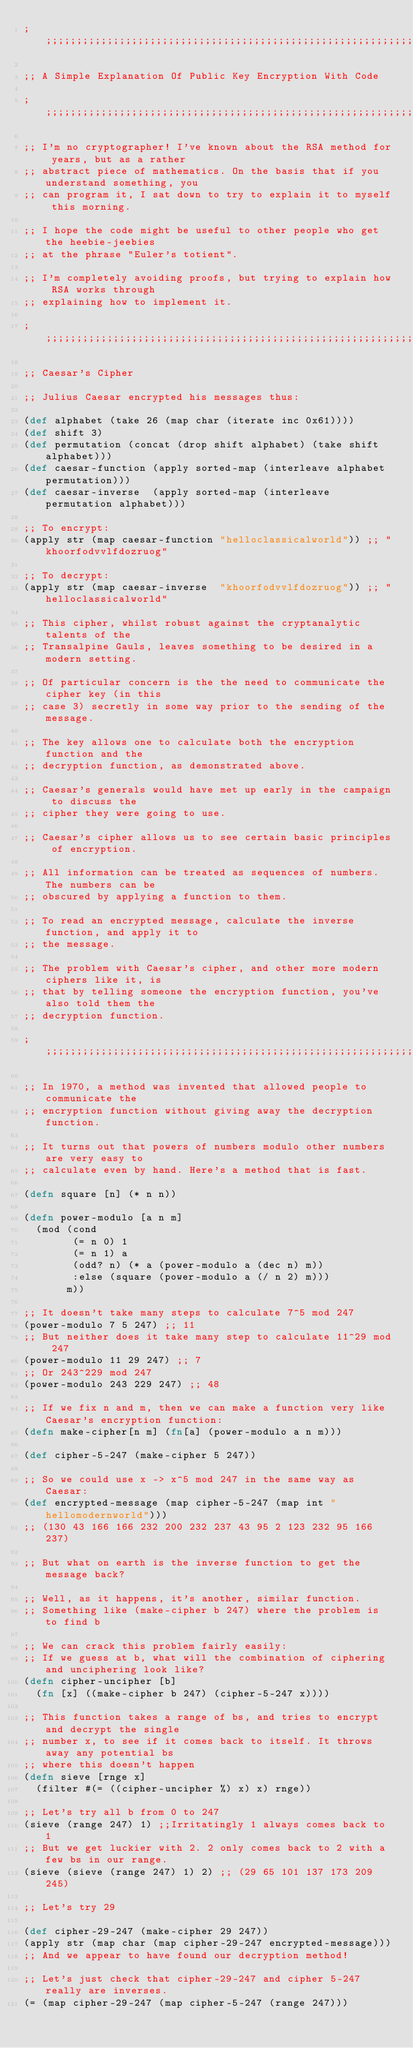<code> <loc_0><loc_0><loc_500><loc_500><_Clojure_>;;;;;;;;;;;;;;;;;;;;;;;;;;;;;;;;;;;;;;;;;;;;;;;;;;;;;;;;;;;;;;;;;;;;;;;;;;;;;;;;;;;;;;;;;;;

;; A Simple Explanation Of Public Key Encryption With Code

;;;;;;;;;;;;;;;;;;;;;;;;;;;;;;;;;;;;;;;;;;;;;;;;;;;;;;;;;;;;;;;;;;;;;;;;;;;;;;;;;;;;;;;;;;;

;; I'm no cryptographer! I've known about the RSA method for years, but as a rather
;; abstract piece of mathematics. On the basis that if you understand something, you
;; can program it, I sat down to try to explain it to myself this morning.

;; I hope the code might be useful to other people who get the heebie-jeebies
;; at the phrase "Euler's totient".

;; I'm completely avoiding proofs, but trying to explain how RSA works through
;; explaining how to implement it.

;;;;;;;;;;;;;;;;;;;;;;;;;;;;;;;;;;;;;;;;;;;;;;;;;;;;;;;;;;;;;;;;;;;;;;;;;;;;;;;;;;;;;;;;;;;;

;; Caesar's Cipher

;; Julius Caesar encrypted his messages thus:

(def alphabet (take 26 (map char (iterate inc 0x61))))
(def shift 3)
(def permutation (concat (drop shift alphabet) (take shift alphabet)))
(def caesar-function (apply sorted-map (interleave alphabet permutation)))
(def caesar-inverse  (apply sorted-map (interleave permutation alphabet)))

;; To encrypt:
(apply str (map caesar-function "helloclassicalworld")) ;; "khoorfodvvlfdozruog"

;; To decrypt:
(apply str (map caesar-inverse  "khoorfodvvlfdozruog")) ;; "helloclassicalworld"

;; This cipher, whilst robust against the cryptanalytic talents of the
;; Transalpine Gauls, leaves something to be desired in a modern setting.

;; Of particular concern is the the need to communicate the cipher key (in this
;; case 3) secretly in some way prior to the sending of the message.

;; The key allows one to calculate both the encryption function and the
;; decryption function, as demonstrated above.

;; Caesar's generals would have met up early in the campaign to discuss the
;; cipher they were going to use.

;; Caesar's cipher allows us to see certain basic principles of encryption.

;; All information can be treated as sequences of numbers.  The numbers can be
;; obscured by applying a function to them.

;; To read an encrypted message, calculate the inverse function, and apply it to
;; the message.

;; The problem with Caesar's cipher, and other more modern ciphers like it, is
;; that by telling someone the encryption function, you've also told them the
;; decryption function.

;;;;;;;;;;;;;;;;;;;;;;;;;;;;;;;;;;;;;;;;;;;;;;;;;;;;;;;;;;;;;;;;;;;;;;;;;;;;;;;;;;;;;;;;;;;;;;;

;; In 1970, a method was invented that allowed people to communicate the
;; encryption function without giving away the decryption function.

;; It turns out that powers of numbers modulo other numbers are very easy to
;; calculate even by hand. Here's a method that is fast.

(defn square [n] (* n n))

(defn power-modulo [a n m]
  (mod (cond
        (= n 0) 1
        (= n 1) a
        (odd? n) (* a (power-modulo a (dec n) m))
        :else (square (power-modulo a (/ n 2) m)))
       m))

;; It doesn't take many steps to calculate 7^5 mod 247 
(power-modulo 7 5 247) ;; 11
;; But neither does it take many step to calculate 11^29 mod 247
(power-modulo 11 29 247) ;; 7
;; Or 243^229 mod 247
(power-modulo 243 229 247) ;; 48

;; If we fix n and m, then we can make a function very like Caesar's encryption function:
(defn make-cipher[n m] (fn[a] (power-modulo a n m)))

(def cipher-5-247 (make-cipher 5 247))

;; So we could use x -> x^5 mod 247 in the same way as Caesar:
(def encrypted-message (map cipher-5-247 (map int "hellomodernworld")))
;; (130 43 166 166 232 200 232 237 43 95 2 123 232 95 166 237)

;; But what on earth is the inverse function to get the message back?

;; Well, as it happens, it's another, similar function.
;; Something like (make-cipher b 247) where the problem is to find b

;; We can crack this problem fairly easily:
;; If we guess at b, what will the combination of ciphering and unciphering look like?
(defn cipher-uncipher [b]
  (fn [x] ((make-cipher b 247) (cipher-5-247 x))))

;; This function takes a range of bs, and tries to encrypt and decrypt the single
;; number x, to see if it comes back to itself. It throws away any potential bs
;; where this doesn't happen
(defn sieve [rnge x]
  (filter #(= ((cipher-uncipher %) x) x) rnge))

;; Let's try all b from 0 to 247
(sieve (range 247) 1) ;;Irritatingly 1 always comes back to 1
;; But we get luckier with 2. 2 only comes back to 2 with a few bs in our range.
(sieve (sieve (range 247) 1) 2) ;; (29 65 101 137 173 209 245)

;; Let's try 29

(def cipher-29-247 (make-cipher 29 247))
(apply str (map char (map cipher-29-247 encrypted-message)))
;; And we appear to have found our decryption method!

;; Let's just check that cipher-29-247 and cipher 5-247 really are inverses.
(= (map cipher-29-247 (map cipher-5-247 (range 247)))</code> 